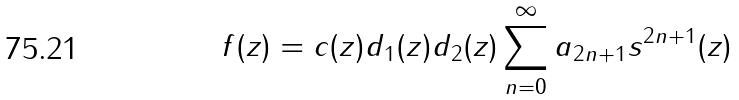<formula> <loc_0><loc_0><loc_500><loc_500>f ( z ) = c ( z ) d _ { 1 } ( z ) d _ { 2 } ( z ) \sum _ { n = 0 } ^ { \infty } a _ { 2 n + 1 } s ^ { 2 n + 1 } ( z )</formula> 